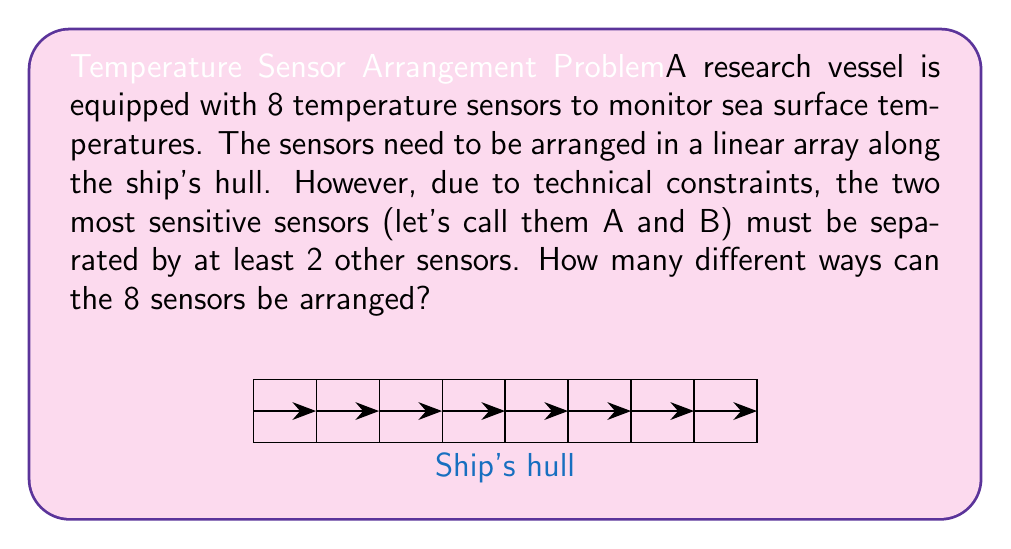Give your solution to this math problem. Let's approach this step-by-step:

1) First, we need to consider the total number of ways to arrange 8 sensors without any restrictions. This would be a simple permutation:

   $$8! = 40,320$$

2) However, we need to subtract the arrangements where A and B are adjacent or separated by only one sensor.

3) To count these invalid arrangements, let's consider A and B as a single unit:
   - If A and B are adjacent, we have 7 units to arrange (AB + 6 other sensors)
   - If A and B are separated by one sensor, we have 3 units to arrange as a block (A_B, where _ is any other sensor) and 5 individual sensors

4) For adjacent A and B:
   - We have 7! ways to arrange the units
   - A and B can be swapped within their unit in 2! ways
   $$7! \cdot 2! = 5,040 \cdot 2 = 10,080$$

5) For A and B separated by one sensor:
   - We have 6! ways to arrange the units (A_B block + 5 sensors)
   - Within the A_B block, we have 2! ways to arrange A and B
   - We have 6 choices for the sensor between A and B
   $$6! \cdot 2! \cdot 6 = 720 \cdot 2 \cdot 6 = 8,640$$

6) Total number of invalid arrangements:
   $$10,080 + 8,640 = 18,720$$

7) Therefore, the number of valid arrangements is:
   $$40,320 - 18,720 = 21,600$$
Answer: 21,600 